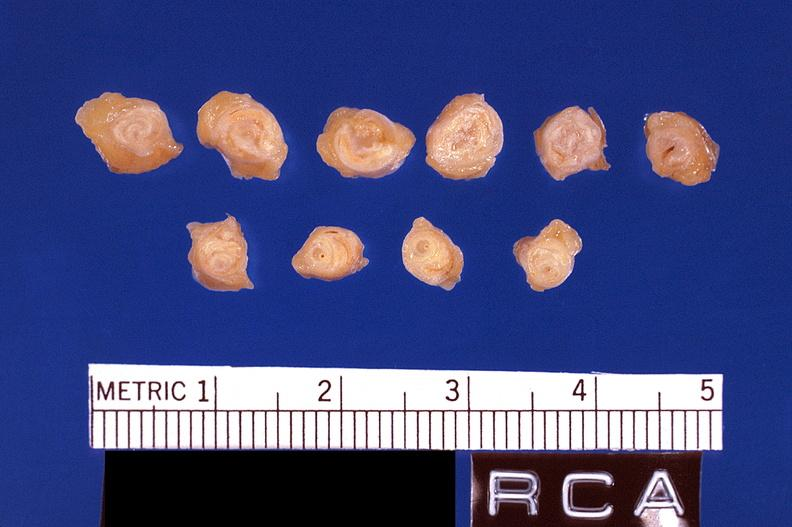what is present?
Answer the question using a single word or phrase. Cardiovascular 